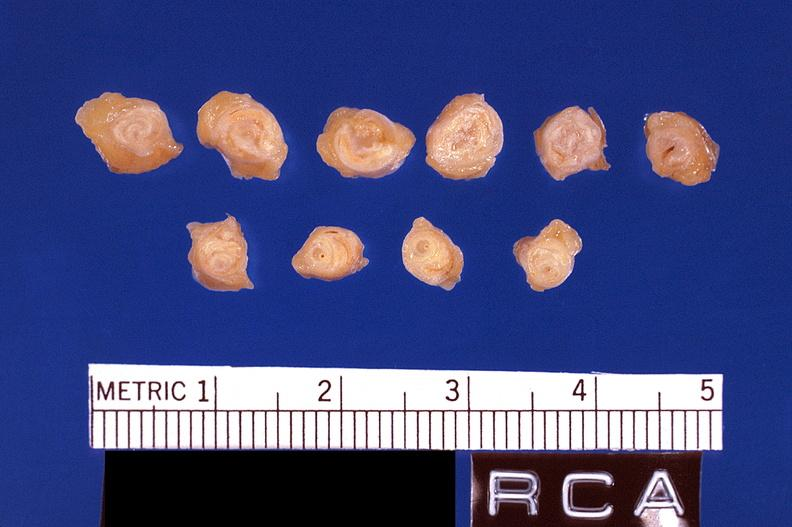what is present?
Answer the question using a single word or phrase. Cardiovascular 